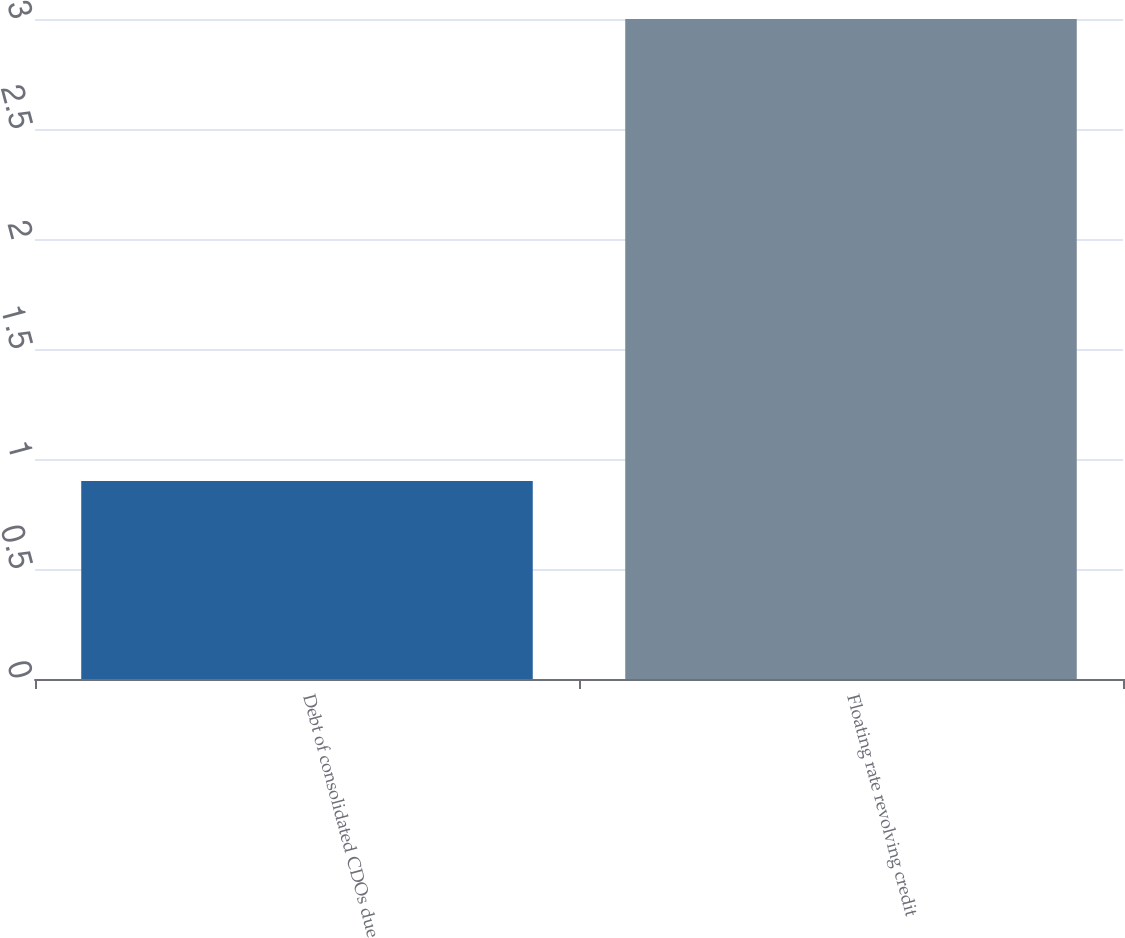Convert chart to OTSL. <chart><loc_0><loc_0><loc_500><loc_500><bar_chart><fcel>Debt of consolidated CDOs due<fcel>Floating rate revolving credit<nl><fcel>0.9<fcel>3<nl></chart> 